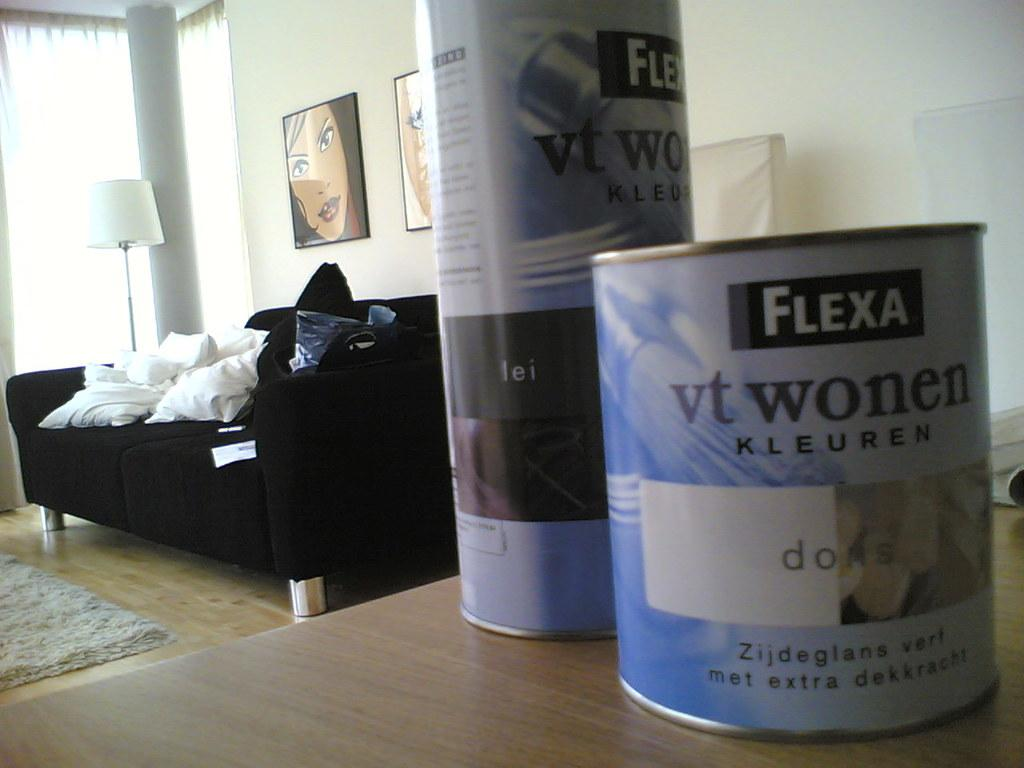<image>
Create a compact narrative representing the image presented. A can of Flexa vt wonen paint on a wooden table. 